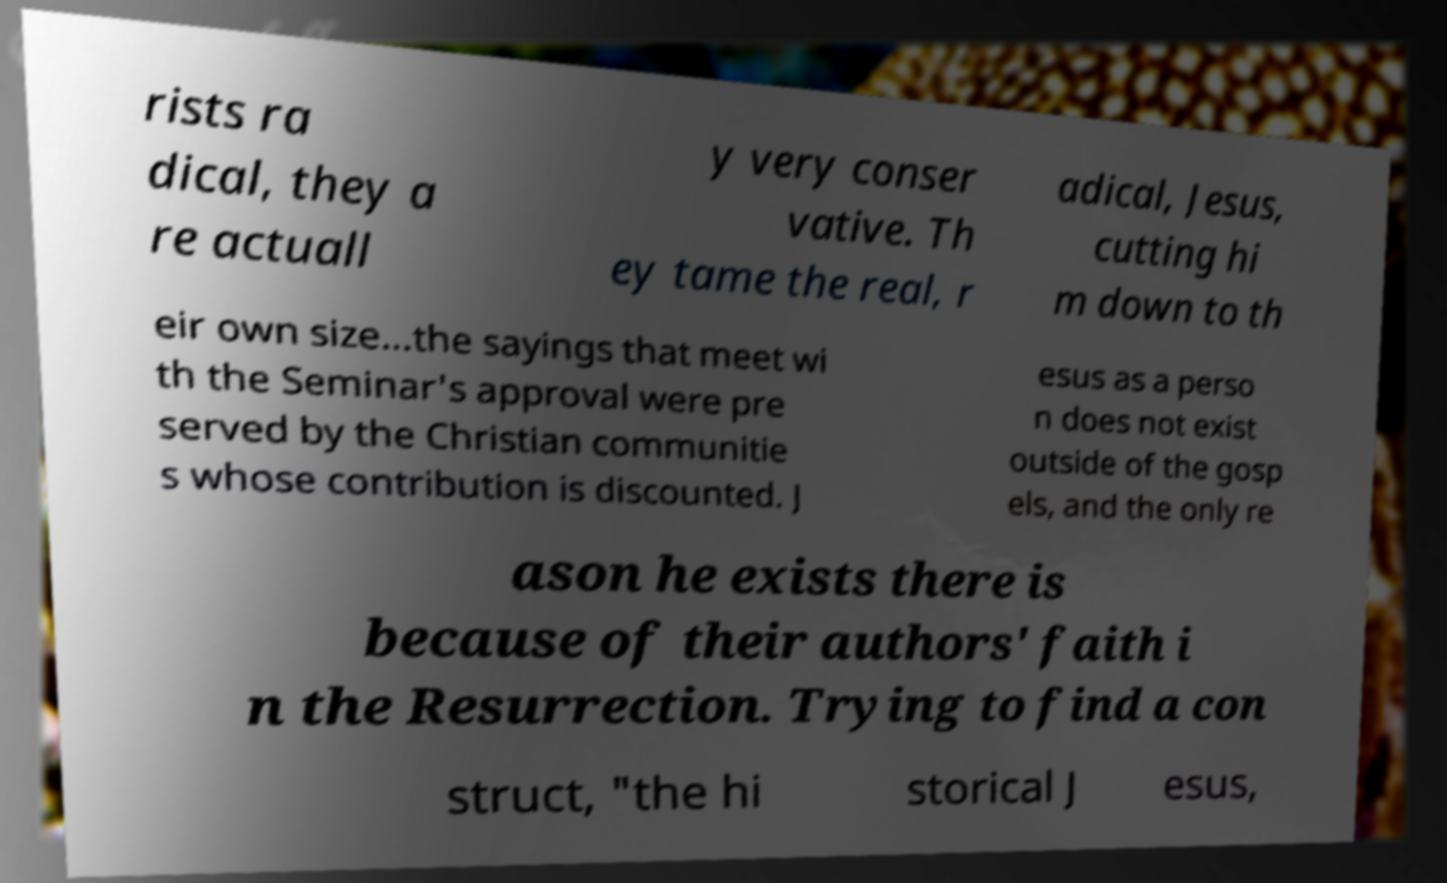Could you extract and type out the text from this image? rists ra dical, they a re actuall y very conser vative. Th ey tame the real, r adical, Jesus, cutting hi m down to th eir own size...the sayings that meet wi th the Seminar's approval were pre served by the Christian communitie s whose contribution is discounted. J esus as a perso n does not exist outside of the gosp els, and the only re ason he exists there is because of their authors' faith i n the Resurrection. Trying to find a con struct, "the hi storical J esus, 